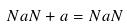Convert formula to latex. <formula><loc_0><loc_0><loc_500><loc_500>N a N + a = N a N</formula> 